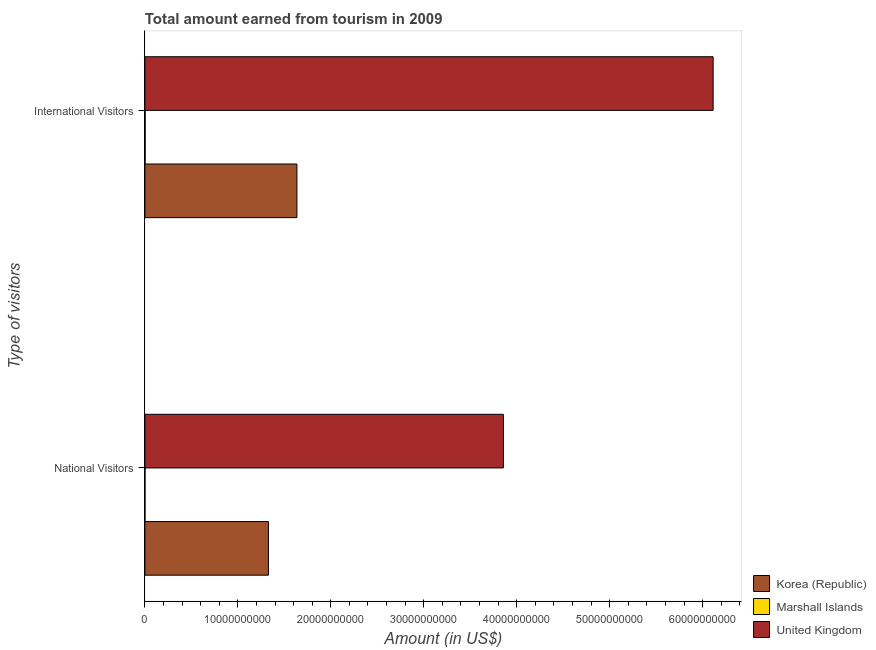How many different coloured bars are there?
Make the answer very short. 3. How many groups of bars are there?
Offer a very short reply. 2. Are the number of bars on each tick of the Y-axis equal?
Keep it short and to the point. Yes. How many bars are there on the 2nd tick from the top?
Provide a short and direct response. 3. What is the label of the 1st group of bars from the top?
Your answer should be compact. International Visitors. What is the amount earned from national visitors in Korea (Republic)?
Offer a terse response. 1.33e+1. Across all countries, what is the maximum amount earned from international visitors?
Your response must be concise. 6.11e+1. Across all countries, what is the minimum amount earned from national visitors?
Your answer should be very brief. 3.08e+06. In which country was the amount earned from international visitors maximum?
Make the answer very short. United Kingdom. In which country was the amount earned from international visitors minimum?
Your response must be concise. Marshall Islands. What is the total amount earned from national visitors in the graph?
Offer a terse response. 5.19e+1. What is the difference between the amount earned from national visitors in United Kingdom and that in Korea (Republic)?
Keep it short and to the point. 2.53e+1. What is the difference between the amount earned from national visitors in Korea (Republic) and the amount earned from international visitors in Marshall Islands?
Your answer should be very brief. 1.33e+1. What is the average amount earned from international visitors per country?
Ensure brevity in your answer.  2.58e+1. What is the difference between the amount earned from international visitors and amount earned from national visitors in Korea (Republic)?
Your answer should be compact. 3.07e+09. What is the ratio of the amount earned from international visitors in United Kingdom to that in Marshall Islands?
Provide a succinct answer. 2490.14. What does the 3rd bar from the top in National Visitors represents?
Offer a very short reply. Korea (Republic). What does the 3rd bar from the bottom in International Visitors represents?
Keep it short and to the point. United Kingdom. How many bars are there?
Keep it short and to the point. 6. Are all the bars in the graph horizontal?
Your answer should be compact. Yes. How many countries are there in the graph?
Your answer should be compact. 3. What is the difference between two consecutive major ticks on the X-axis?
Make the answer very short. 1.00e+1. Where does the legend appear in the graph?
Provide a short and direct response. Bottom right. How are the legend labels stacked?
Provide a succinct answer. Vertical. What is the title of the graph?
Provide a succinct answer. Total amount earned from tourism in 2009. What is the label or title of the Y-axis?
Your answer should be compact. Type of visitors. What is the Amount (in US$) in Korea (Republic) in National Visitors?
Keep it short and to the point. 1.33e+1. What is the Amount (in US$) of Marshall Islands in National Visitors?
Offer a terse response. 3.08e+06. What is the Amount (in US$) of United Kingdom in National Visitors?
Ensure brevity in your answer.  3.86e+1. What is the Amount (in US$) of Korea (Republic) in International Visitors?
Your answer should be very brief. 1.64e+1. What is the Amount (in US$) of Marshall Islands in International Visitors?
Your response must be concise. 2.46e+07. What is the Amount (in US$) in United Kingdom in International Visitors?
Give a very brief answer. 6.11e+1. Across all Type of visitors, what is the maximum Amount (in US$) of Korea (Republic)?
Provide a short and direct response. 1.64e+1. Across all Type of visitors, what is the maximum Amount (in US$) in Marshall Islands?
Your response must be concise. 2.46e+07. Across all Type of visitors, what is the maximum Amount (in US$) in United Kingdom?
Make the answer very short. 6.11e+1. Across all Type of visitors, what is the minimum Amount (in US$) in Korea (Republic)?
Give a very brief answer. 1.33e+1. Across all Type of visitors, what is the minimum Amount (in US$) in Marshall Islands?
Offer a terse response. 3.08e+06. Across all Type of visitors, what is the minimum Amount (in US$) in United Kingdom?
Offer a terse response. 3.86e+1. What is the total Amount (in US$) in Korea (Republic) in the graph?
Give a very brief answer. 2.96e+1. What is the total Amount (in US$) in Marshall Islands in the graph?
Make the answer very short. 2.76e+07. What is the total Amount (in US$) of United Kingdom in the graph?
Keep it short and to the point. 9.97e+1. What is the difference between the Amount (in US$) of Korea (Republic) in National Visitors and that in International Visitors?
Ensure brevity in your answer.  -3.07e+09. What is the difference between the Amount (in US$) of Marshall Islands in National Visitors and that in International Visitors?
Offer a very short reply. -2.15e+07. What is the difference between the Amount (in US$) in United Kingdom in National Visitors and that in International Visitors?
Your response must be concise. -2.26e+1. What is the difference between the Amount (in US$) in Korea (Republic) in National Visitors and the Amount (in US$) in Marshall Islands in International Visitors?
Your response must be concise. 1.33e+1. What is the difference between the Amount (in US$) in Korea (Republic) in National Visitors and the Amount (in US$) in United Kingdom in International Visitors?
Offer a terse response. -4.78e+1. What is the difference between the Amount (in US$) in Marshall Islands in National Visitors and the Amount (in US$) in United Kingdom in International Visitors?
Offer a very short reply. -6.11e+1. What is the average Amount (in US$) of Korea (Republic) per Type of visitors?
Keep it short and to the point. 1.48e+1. What is the average Amount (in US$) of Marshall Islands per Type of visitors?
Provide a succinct answer. 1.38e+07. What is the average Amount (in US$) in United Kingdom per Type of visitors?
Ensure brevity in your answer.  4.98e+1. What is the difference between the Amount (in US$) in Korea (Republic) and Amount (in US$) in Marshall Islands in National Visitors?
Your answer should be compact. 1.33e+1. What is the difference between the Amount (in US$) in Korea (Republic) and Amount (in US$) in United Kingdom in National Visitors?
Your response must be concise. -2.53e+1. What is the difference between the Amount (in US$) in Marshall Islands and Amount (in US$) in United Kingdom in National Visitors?
Provide a short and direct response. -3.86e+1. What is the difference between the Amount (in US$) in Korea (Republic) and Amount (in US$) in Marshall Islands in International Visitors?
Provide a succinct answer. 1.63e+1. What is the difference between the Amount (in US$) in Korea (Republic) and Amount (in US$) in United Kingdom in International Visitors?
Make the answer very short. -4.48e+1. What is the difference between the Amount (in US$) in Marshall Islands and Amount (in US$) in United Kingdom in International Visitors?
Provide a succinct answer. -6.11e+1. What is the ratio of the Amount (in US$) in Korea (Republic) in National Visitors to that in International Visitors?
Give a very brief answer. 0.81. What is the ratio of the Amount (in US$) in Marshall Islands in National Visitors to that in International Visitors?
Make the answer very short. 0.13. What is the ratio of the Amount (in US$) of United Kingdom in National Visitors to that in International Visitors?
Your answer should be very brief. 0.63. What is the difference between the highest and the second highest Amount (in US$) of Korea (Republic)?
Ensure brevity in your answer.  3.07e+09. What is the difference between the highest and the second highest Amount (in US$) of Marshall Islands?
Your answer should be compact. 2.15e+07. What is the difference between the highest and the second highest Amount (in US$) of United Kingdom?
Your response must be concise. 2.26e+1. What is the difference between the highest and the lowest Amount (in US$) in Korea (Republic)?
Your answer should be compact. 3.07e+09. What is the difference between the highest and the lowest Amount (in US$) of Marshall Islands?
Ensure brevity in your answer.  2.15e+07. What is the difference between the highest and the lowest Amount (in US$) in United Kingdom?
Ensure brevity in your answer.  2.26e+1. 